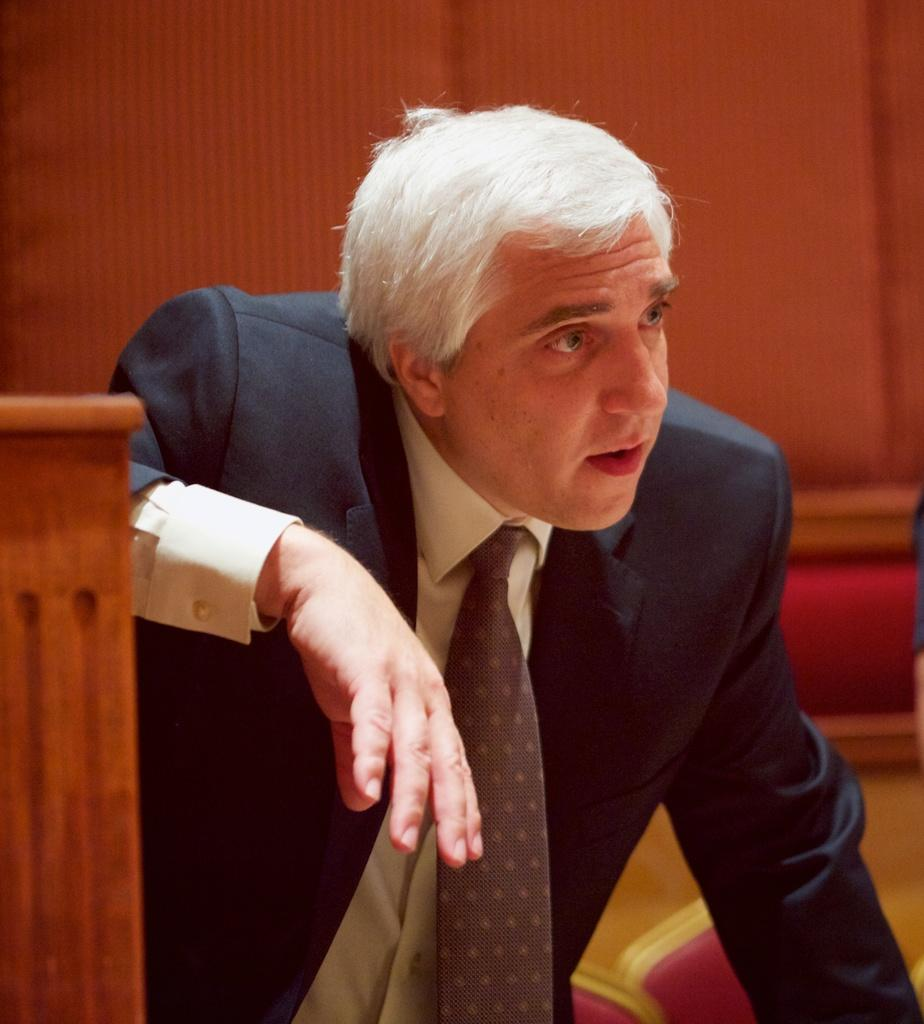What is the person in the image wearing? The person in the image is wearing a suit. What can be seen on the left side of the image? There is a wooden object on the left side of the image. What is located at the bottom of the image? There are objects at the bottom of the image. How would you describe the background of the image? The background of the image has a blurred view. How many boys are playing in the dirt in the image? There are no boys playing in the dirt in the image, as it does not depict any dirt or boys. 